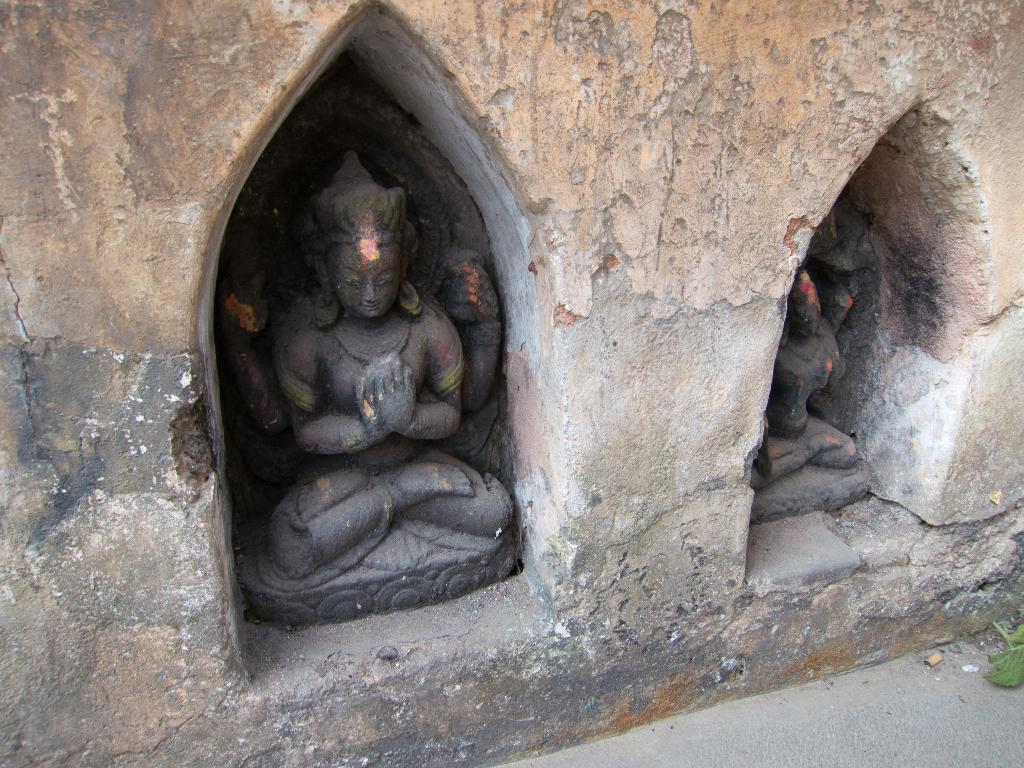What can be seen inside the wall in the image? There are two idols inside the wall in the image. What is present on the floor in the right bottom of the image? There is a leaf on the floor in the right bottom of the image. What song is being performed on the stage in the image? There is no stage present in the image, so it is not possible to determine if a song is being performed. 